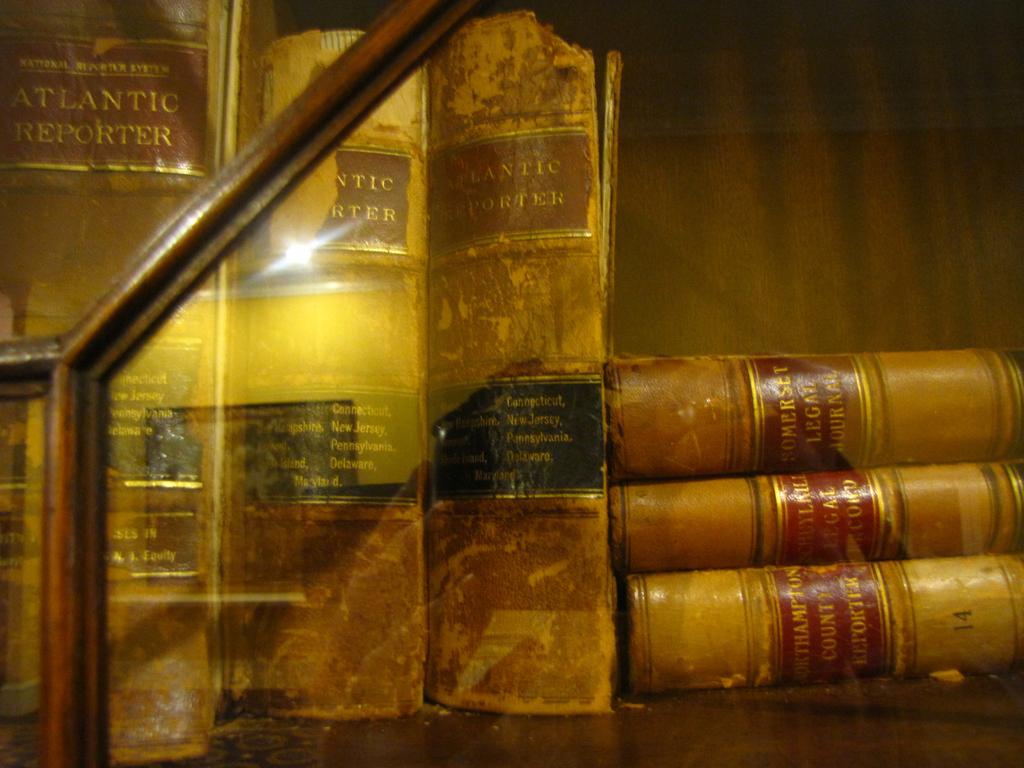What is the title of the first book that is upright?
Make the answer very short. Atlantic reporter. What is the name of the second book?
Provide a succinct answer. Unanswerable. 